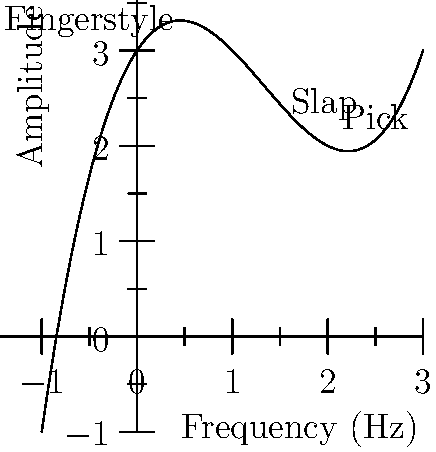The graph above represents the harmonic overtones produced by different bass playing techniques. The x-axis represents frequency in Hz, and the y-axis represents amplitude. The polynomial function that models this relationship is given by $f(x) = 0.5x^3 - 2x^2 + 1.5x + 3$, where $x$ is the frequency and $f(x)$ is the amplitude. At what frequency does the slap technique produce its maximum amplitude? To find the frequency at which the slap technique produces its maximum amplitude, we need to follow these steps:

1) The maximum point on a polynomial graph occurs where its derivative equals zero. So, we need to find $f'(x)$ and set it to zero.

2) $f(x) = 0.5x^3 - 2x^2 + 1.5x + 3$
   $f'(x) = 1.5x^2 - 4x + 1.5$

3) Set $f'(x) = 0$:
   $1.5x^2 - 4x + 1.5 = 0$

4) This is a quadratic equation. We can solve it using the quadratic formula:
   $x = \frac{-b \pm \sqrt{b^2 - 4ac}}{2a}$

   Where $a = 1.5$, $b = -4$, and $c = 1.5$

5) Plugging these values into the quadratic formula:
   $x = \frac{4 \pm \sqrt{16 - 4(1.5)(1.5)}}{2(1.5)}$
   $= \frac{4 \pm \sqrt{7}}{3}$

6) This gives us two solutions: $x_1 = \frac{4 + \sqrt{7}}{3}$ and $x_2 = \frac{4 - \sqrt{7}}{3}$

7) Looking at the graph, we can see that the slap technique's peak is at the higher x-value, which corresponds to $x_1$.

8) $x_1 = \frac{4 + \sqrt{7}}{3} \approx 2.22$ Hz

Therefore, the slap technique produces its maximum amplitude at approximately 2.22 Hz.
Answer: 2.22 Hz 